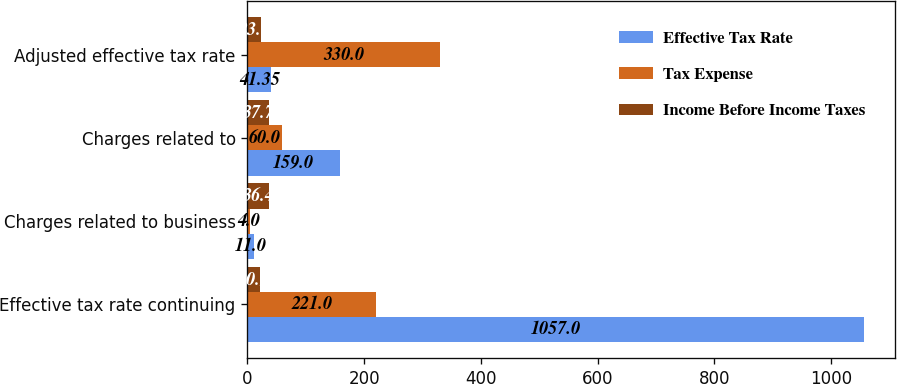Convert chart to OTSL. <chart><loc_0><loc_0><loc_500><loc_500><stacked_bar_chart><ecel><fcel>Effective tax rate continuing<fcel>Charges related to business<fcel>Charges related to<fcel>Adjusted effective tax rate<nl><fcel>Effective Tax Rate<fcel>1057<fcel>11<fcel>159<fcel>41.35<nl><fcel>Tax Expense<fcel>221<fcel>4<fcel>60<fcel>330<nl><fcel>Income Before Income Taxes<fcel>20.9<fcel>36.4<fcel>37.7<fcel>23<nl></chart> 